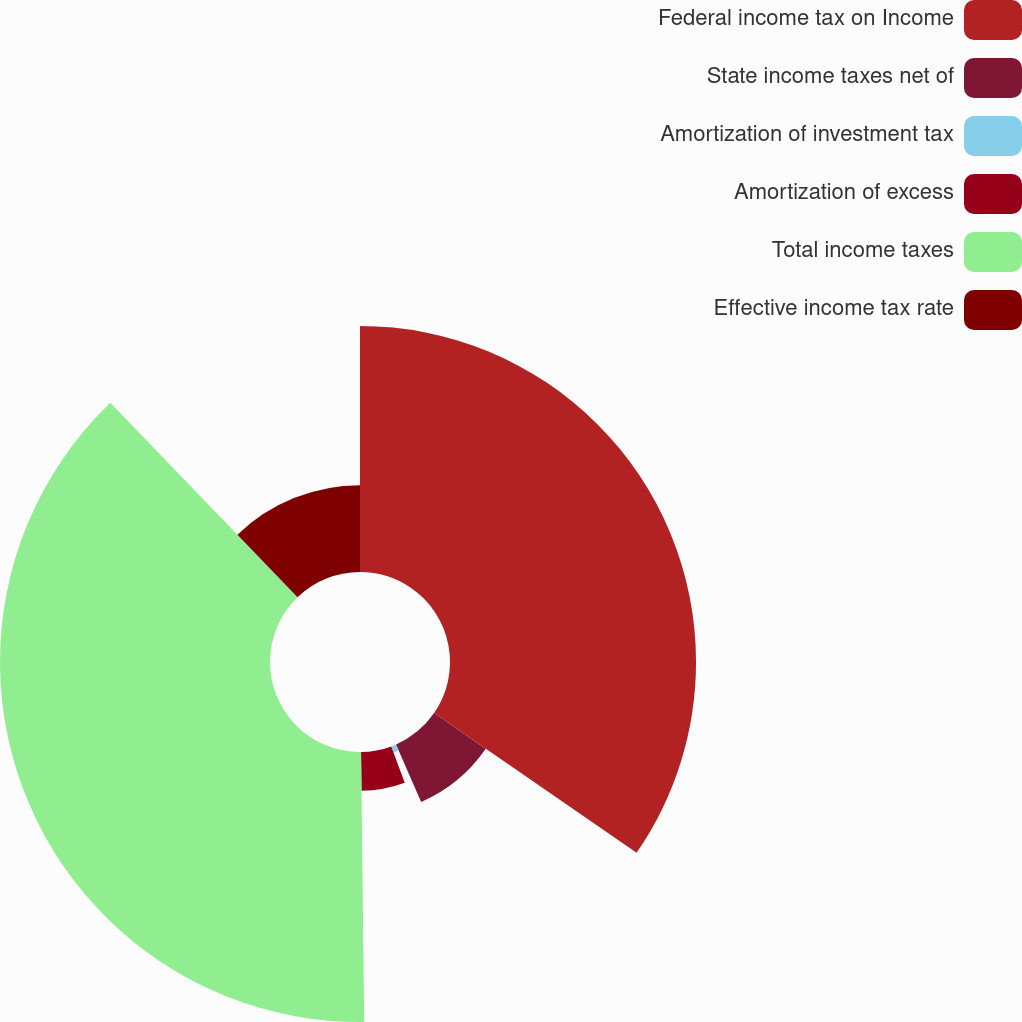Convert chart to OTSL. <chart><loc_0><loc_0><loc_500><loc_500><pie_chart><fcel>Federal income tax on Income<fcel>State income taxes net of<fcel>Amortization of investment tax<fcel>Amortization of excess<fcel>Total income taxes<fcel>Effective income tax rate<nl><fcel>34.61%<fcel>8.83%<fcel>0.91%<fcel>5.46%<fcel>37.98%<fcel>12.2%<nl></chart> 